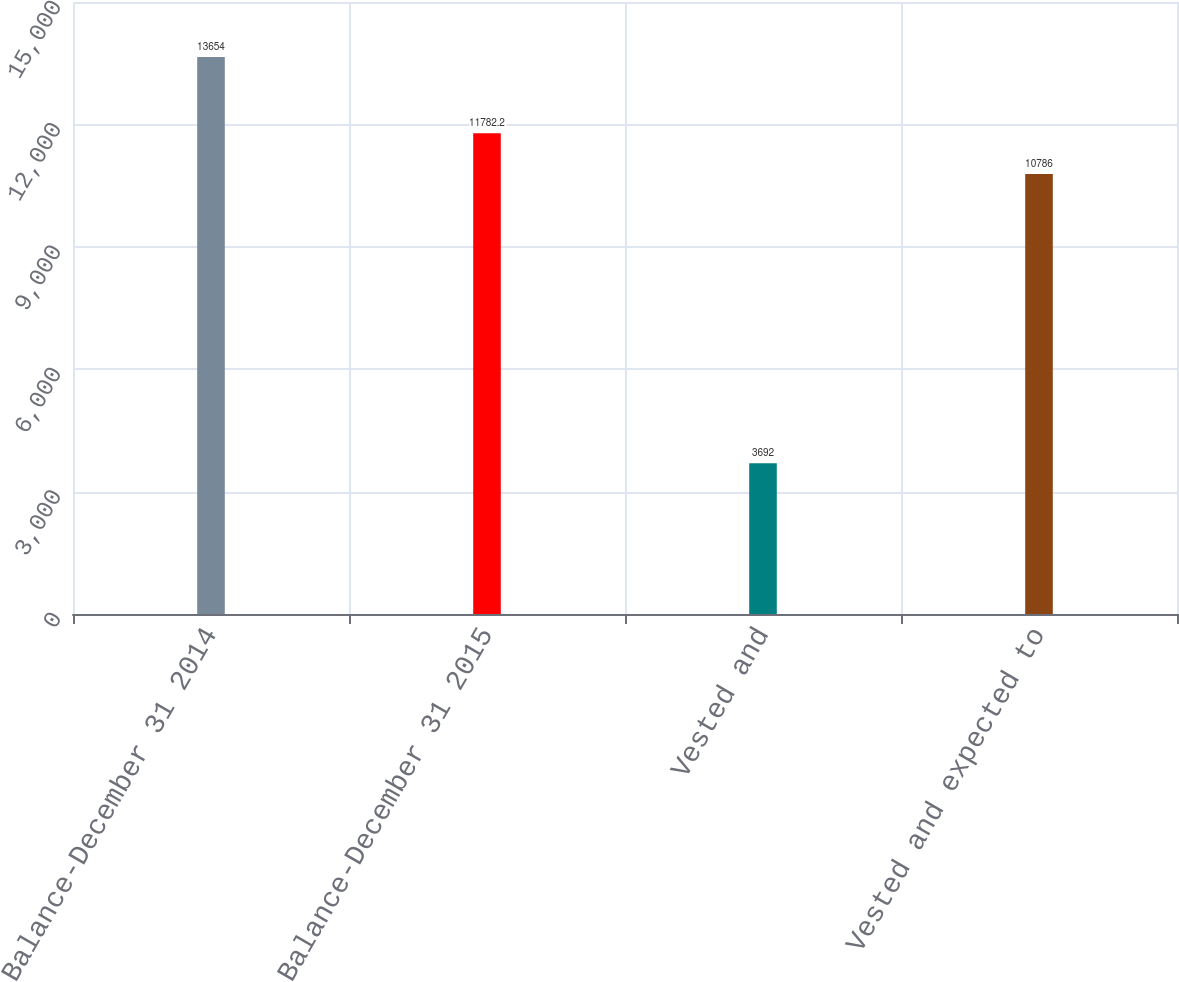Convert chart. <chart><loc_0><loc_0><loc_500><loc_500><bar_chart><fcel>Balance-December 31 2014<fcel>Balance-December 31 2015<fcel>Vested and<fcel>Vested and expected to<nl><fcel>13654<fcel>11782.2<fcel>3692<fcel>10786<nl></chart> 